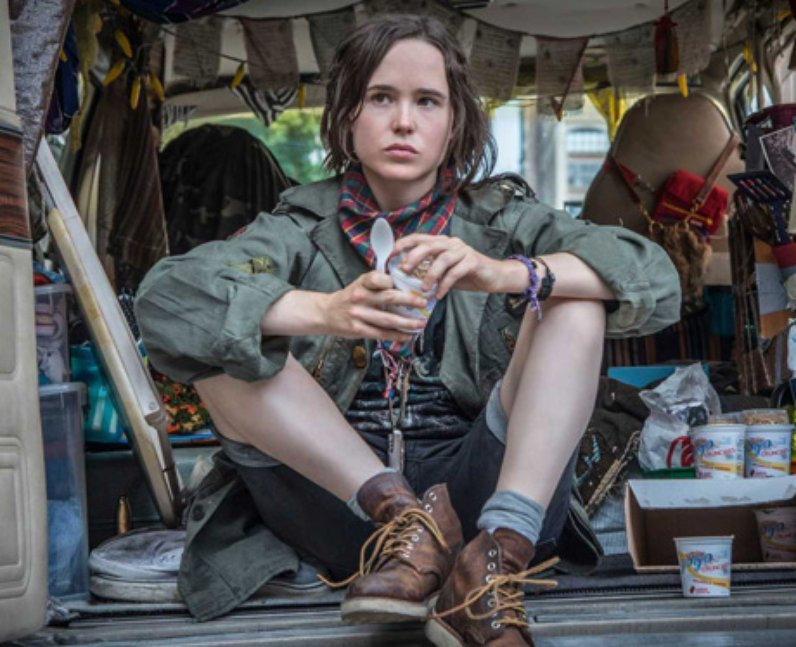Can you elaborate on the elements of the picture provided? In this image, a person is seated in what appears to be a van, surrounded by various objects that hang from the ceiling and are scattered around the floor. Dressed in a green jacket, a red scarf, and brown boots, they hold a cup in their hands and a spoon close to their mouth, possibly eating. The overall scene is cluttered yet cozy, suggesting a transient or mobile lifestyle. Their expression is serious, suggesting deep thought or introspection. The van itself has a lived-in feel, with personal items and decorations adding to the sense of this being a personal space. 